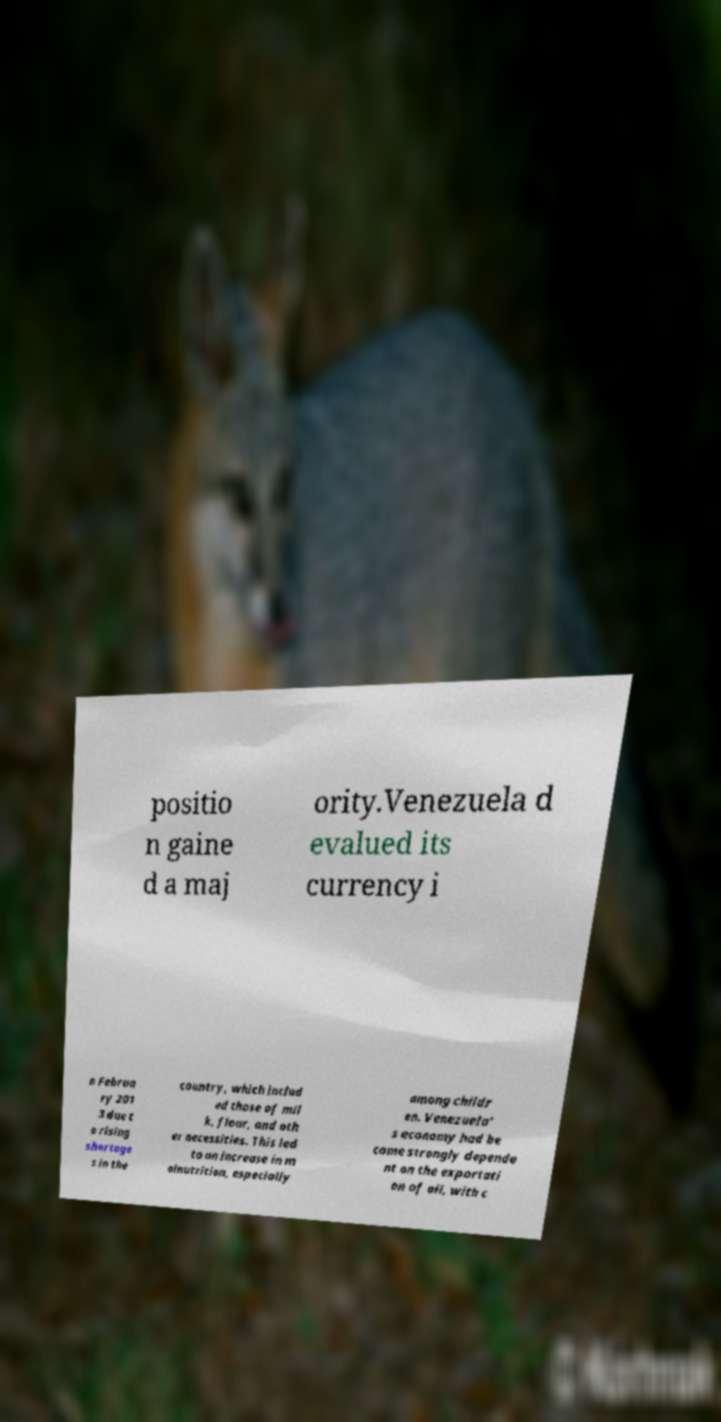What messages or text are displayed in this image? I need them in a readable, typed format. positio n gaine d a maj ority.Venezuela d evalued its currency i n Februa ry 201 3 due t o rising shortage s in the country, which includ ed those of mil k, flour, and oth er necessities. This led to an increase in m alnutrition, especially among childr en. Venezuela' s economy had be come strongly depende nt on the exportati on of oil, with c 